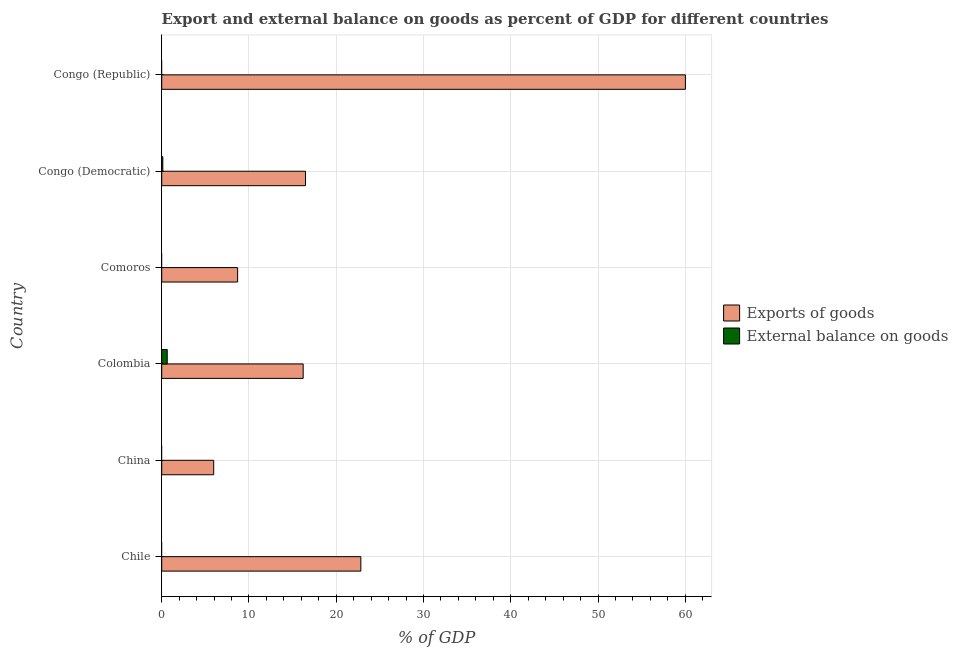How many different coloured bars are there?
Your answer should be compact. 2. Are the number of bars per tick equal to the number of legend labels?
Provide a short and direct response. No. What is the label of the 2nd group of bars from the top?
Your answer should be compact. Congo (Democratic). In how many cases, is the number of bars for a given country not equal to the number of legend labels?
Provide a short and direct response. 4. What is the export of goods as percentage of gdp in Comoros?
Offer a terse response. 8.7. Across all countries, what is the maximum export of goods as percentage of gdp?
Give a very brief answer. 60.02. Across all countries, what is the minimum export of goods as percentage of gdp?
Provide a short and direct response. 5.96. What is the total export of goods as percentage of gdp in the graph?
Your answer should be compact. 130.18. What is the difference between the export of goods as percentage of gdp in Colombia and that in Congo (Democratic)?
Your response must be concise. -0.27. What is the difference between the external balance on goods as percentage of gdp in Congo (Democratic) and the export of goods as percentage of gdp in Chile?
Give a very brief answer. -22.69. What is the average external balance on goods as percentage of gdp per country?
Give a very brief answer. 0.13. What is the difference between the export of goods as percentage of gdp and external balance on goods as percentage of gdp in Colombia?
Offer a very short reply. 15.58. In how many countries, is the export of goods as percentage of gdp greater than 6 %?
Your response must be concise. 5. What is the ratio of the export of goods as percentage of gdp in Congo (Democratic) to that in Congo (Republic)?
Keep it short and to the point. 0.28. Is the difference between the export of goods as percentage of gdp in Colombia and Congo (Democratic) greater than the difference between the external balance on goods as percentage of gdp in Colombia and Congo (Democratic)?
Provide a succinct answer. No. What is the difference between the highest and the second highest export of goods as percentage of gdp?
Your answer should be very brief. 37.2. What is the difference between the highest and the lowest export of goods as percentage of gdp?
Offer a terse response. 54.06. Are all the bars in the graph horizontal?
Keep it short and to the point. Yes. What is the difference between two consecutive major ticks on the X-axis?
Make the answer very short. 10. Are the values on the major ticks of X-axis written in scientific E-notation?
Give a very brief answer. No. Does the graph contain any zero values?
Offer a very short reply. Yes. Does the graph contain grids?
Offer a terse response. Yes. Where does the legend appear in the graph?
Your response must be concise. Center right. How many legend labels are there?
Your answer should be very brief. 2. How are the legend labels stacked?
Your answer should be compact. Vertical. What is the title of the graph?
Your response must be concise. Export and external balance on goods as percent of GDP for different countries. Does "Investment in Transport" appear as one of the legend labels in the graph?
Your answer should be compact. No. What is the label or title of the X-axis?
Keep it short and to the point. % of GDP. What is the % of GDP of Exports of goods in Chile?
Provide a short and direct response. 22.82. What is the % of GDP of External balance on goods in Chile?
Your response must be concise. 0. What is the % of GDP of Exports of goods in China?
Ensure brevity in your answer.  5.96. What is the % of GDP in External balance on goods in China?
Make the answer very short. 0. What is the % of GDP in Exports of goods in Colombia?
Make the answer very short. 16.21. What is the % of GDP in External balance on goods in Colombia?
Keep it short and to the point. 0.63. What is the % of GDP of Exports of goods in Comoros?
Make the answer very short. 8.7. What is the % of GDP in Exports of goods in Congo (Democratic)?
Offer a terse response. 16.48. What is the % of GDP in External balance on goods in Congo (Democratic)?
Provide a succinct answer. 0.13. What is the % of GDP of Exports of goods in Congo (Republic)?
Offer a terse response. 60.02. What is the % of GDP of External balance on goods in Congo (Republic)?
Offer a terse response. 0. Across all countries, what is the maximum % of GDP of Exports of goods?
Provide a succinct answer. 60.02. Across all countries, what is the maximum % of GDP in External balance on goods?
Ensure brevity in your answer.  0.63. Across all countries, what is the minimum % of GDP in Exports of goods?
Make the answer very short. 5.96. What is the total % of GDP in Exports of goods in the graph?
Provide a short and direct response. 130.18. What is the total % of GDP of External balance on goods in the graph?
Your answer should be very brief. 0.76. What is the difference between the % of GDP of Exports of goods in Chile and that in China?
Your answer should be compact. 16.86. What is the difference between the % of GDP of Exports of goods in Chile and that in Colombia?
Your answer should be very brief. 6.61. What is the difference between the % of GDP in Exports of goods in Chile and that in Comoros?
Your response must be concise. 14.12. What is the difference between the % of GDP of Exports of goods in Chile and that in Congo (Democratic)?
Your answer should be very brief. 6.34. What is the difference between the % of GDP of Exports of goods in Chile and that in Congo (Republic)?
Your answer should be very brief. -37.2. What is the difference between the % of GDP in Exports of goods in China and that in Colombia?
Make the answer very short. -10.25. What is the difference between the % of GDP of Exports of goods in China and that in Comoros?
Keep it short and to the point. -2.74. What is the difference between the % of GDP of Exports of goods in China and that in Congo (Democratic)?
Provide a succinct answer. -10.52. What is the difference between the % of GDP in Exports of goods in China and that in Congo (Republic)?
Your response must be concise. -54.06. What is the difference between the % of GDP of Exports of goods in Colombia and that in Comoros?
Your answer should be very brief. 7.51. What is the difference between the % of GDP of Exports of goods in Colombia and that in Congo (Democratic)?
Give a very brief answer. -0.27. What is the difference between the % of GDP in External balance on goods in Colombia and that in Congo (Democratic)?
Offer a very short reply. 0.51. What is the difference between the % of GDP in Exports of goods in Colombia and that in Congo (Republic)?
Give a very brief answer. -43.81. What is the difference between the % of GDP in Exports of goods in Comoros and that in Congo (Democratic)?
Your answer should be compact. -7.78. What is the difference between the % of GDP of Exports of goods in Comoros and that in Congo (Republic)?
Offer a very short reply. -51.32. What is the difference between the % of GDP of Exports of goods in Congo (Democratic) and that in Congo (Republic)?
Ensure brevity in your answer.  -43.54. What is the difference between the % of GDP of Exports of goods in Chile and the % of GDP of External balance on goods in Colombia?
Keep it short and to the point. 22.19. What is the difference between the % of GDP in Exports of goods in Chile and the % of GDP in External balance on goods in Congo (Democratic)?
Make the answer very short. 22.69. What is the difference between the % of GDP in Exports of goods in China and the % of GDP in External balance on goods in Colombia?
Keep it short and to the point. 5.33. What is the difference between the % of GDP in Exports of goods in China and the % of GDP in External balance on goods in Congo (Democratic)?
Your answer should be compact. 5.83. What is the difference between the % of GDP in Exports of goods in Colombia and the % of GDP in External balance on goods in Congo (Democratic)?
Keep it short and to the point. 16.08. What is the difference between the % of GDP of Exports of goods in Comoros and the % of GDP of External balance on goods in Congo (Democratic)?
Ensure brevity in your answer.  8.57. What is the average % of GDP in Exports of goods per country?
Offer a very short reply. 21.7. What is the average % of GDP of External balance on goods per country?
Your answer should be very brief. 0.13. What is the difference between the % of GDP in Exports of goods and % of GDP in External balance on goods in Colombia?
Your response must be concise. 15.58. What is the difference between the % of GDP in Exports of goods and % of GDP in External balance on goods in Congo (Democratic)?
Your answer should be compact. 16.35. What is the ratio of the % of GDP in Exports of goods in Chile to that in China?
Provide a succinct answer. 3.83. What is the ratio of the % of GDP of Exports of goods in Chile to that in Colombia?
Your answer should be very brief. 1.41. What is the ratio of the % of GDP of Exports of goods in Chile to that in Comoros?
Your answer should be very brief. 2.62. What is the ratio of the % of GDP of Exports of goods in Chile to that in Congo (Democratic)?
Provide a short and direct response. 1.38. What is the ratio of the % of GDP of Exports of goods in Chile to that in Congo (Republic)?
Your answer should be very brief. 0.38. What is the ratio of the % of GDP of Exports of goods in China to that in Colombia?
Offer a very short reply. 0.37. What is the ratio of the % of GDP of Exports of goods in China to that in Comoros?
Provide a short and direct response. 0.68. What is the ratio of the % of GDP in Exports of goods in China to that in Congo (Democratic)?
Keep it short and to the point. 0.36. What is the ratio of the % of GDP of Exports of goods in China to that in Congo (Republic)?
Provide a short and direct response. 0.1. What is the ratio of the % of GDP of Exports of goods in Colombia to that in Comoros?
Offer a very short reply. 1.86. What is the ratio of the % of GDP in Exports of goods in Colombia to that in Congo (Democratic)?
Your answer should be compact. 0.98. What is the ratio of the % of GDP in External balance on goods in Colombia to that in Congo (Democratic)?
Ensure brevity in your answer.  5. What is the ratio of the % of GDP in Exports of goods in Colombia to that in Congo (Republic)?
Provide a short and direct response. 0.27. What is the ratio of the % of GDP of Exports of goods in Comoros to that in Congo (Democratic)?
Offer a very short reply. 0.53. What is the ratio of the % of GDP of Exports of goods in Comoros to that in Congo (Republic)?
Your response must be concise. 0.14. What is the ratio of the % of GDP of Exports of goods in Congo (Democratic) to that in Congo (Republic)?
Keep it short and to the point. 0.27. What is the difference between the highest and the second highest % of GDP in Exports of goods?
Keep it short and to the point. 37.2. What is the difference between the highest and the lowest % of GDP of Exports of goods?
Your response must be concise. 54.06. What is the difference between the highest and the lowest % of GDP of External balance on goods?
Your response must be concise. 0.63. 